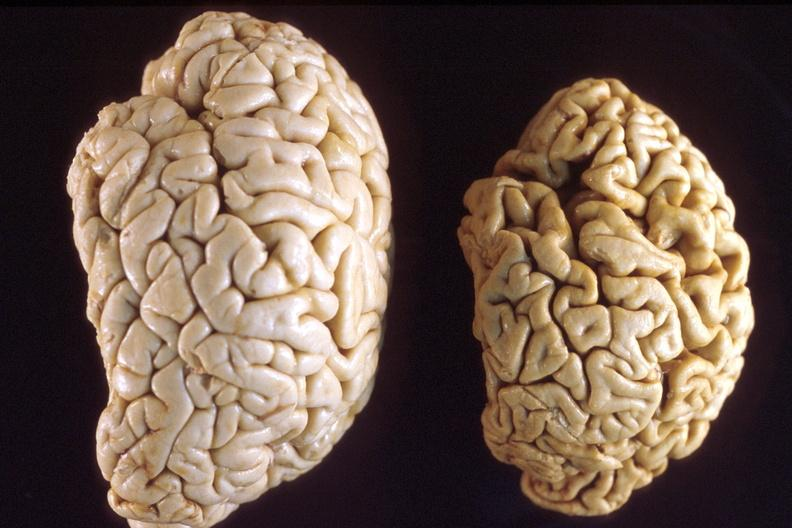s gout present?
Answer the question using a single word or phrase. No 